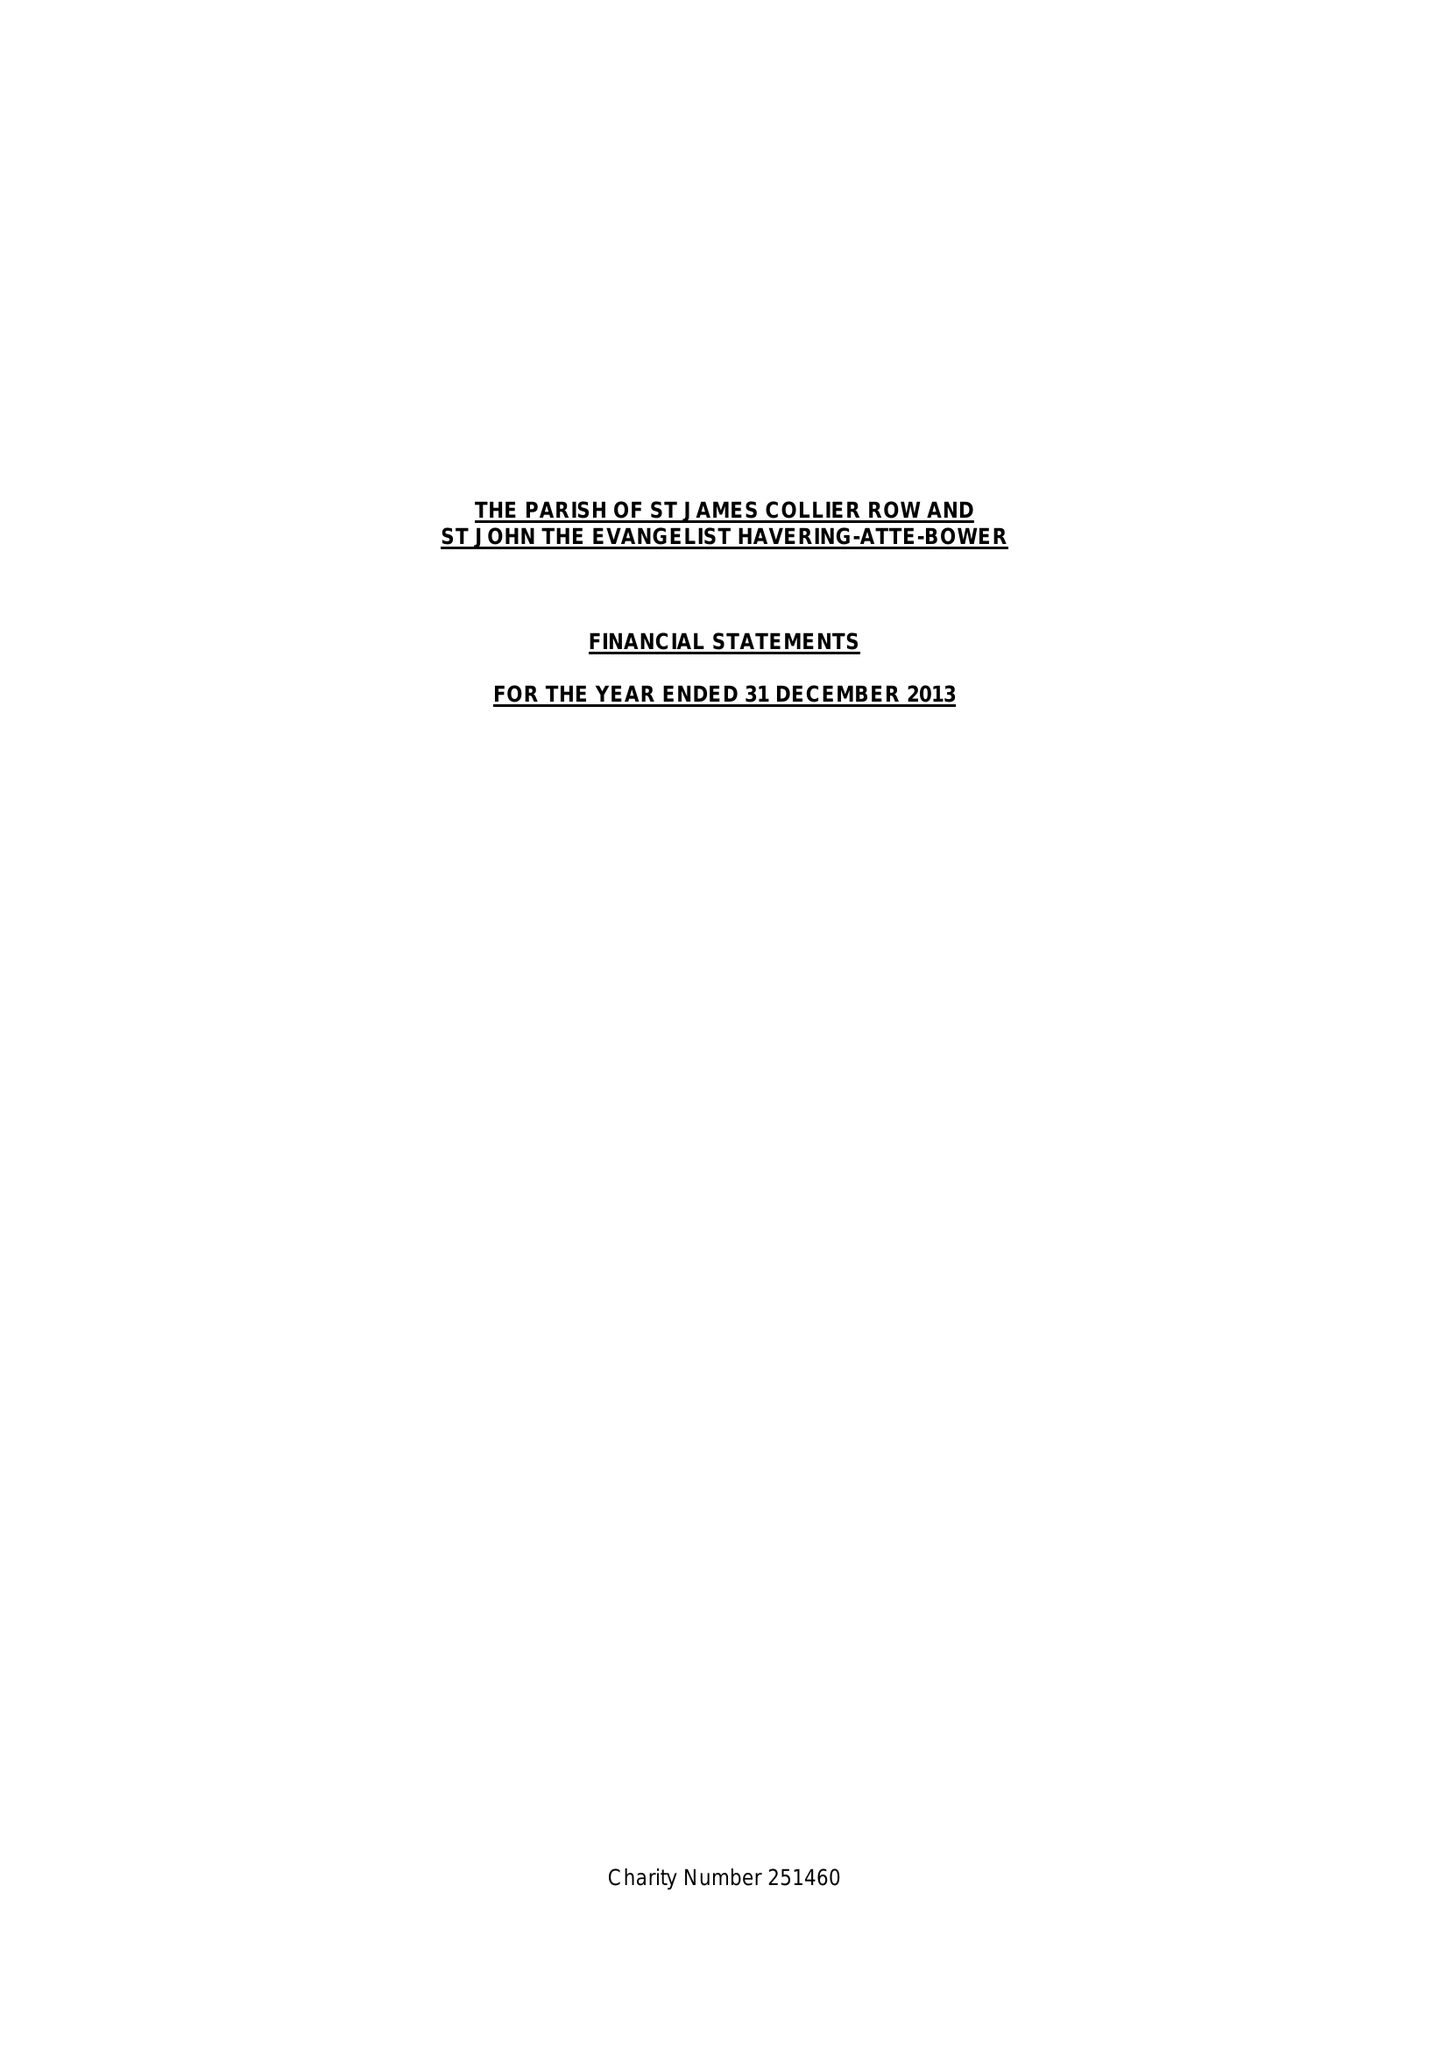What is the value for the address__postcode?
Answer the question using a single word or phrase. RM2 6NB 